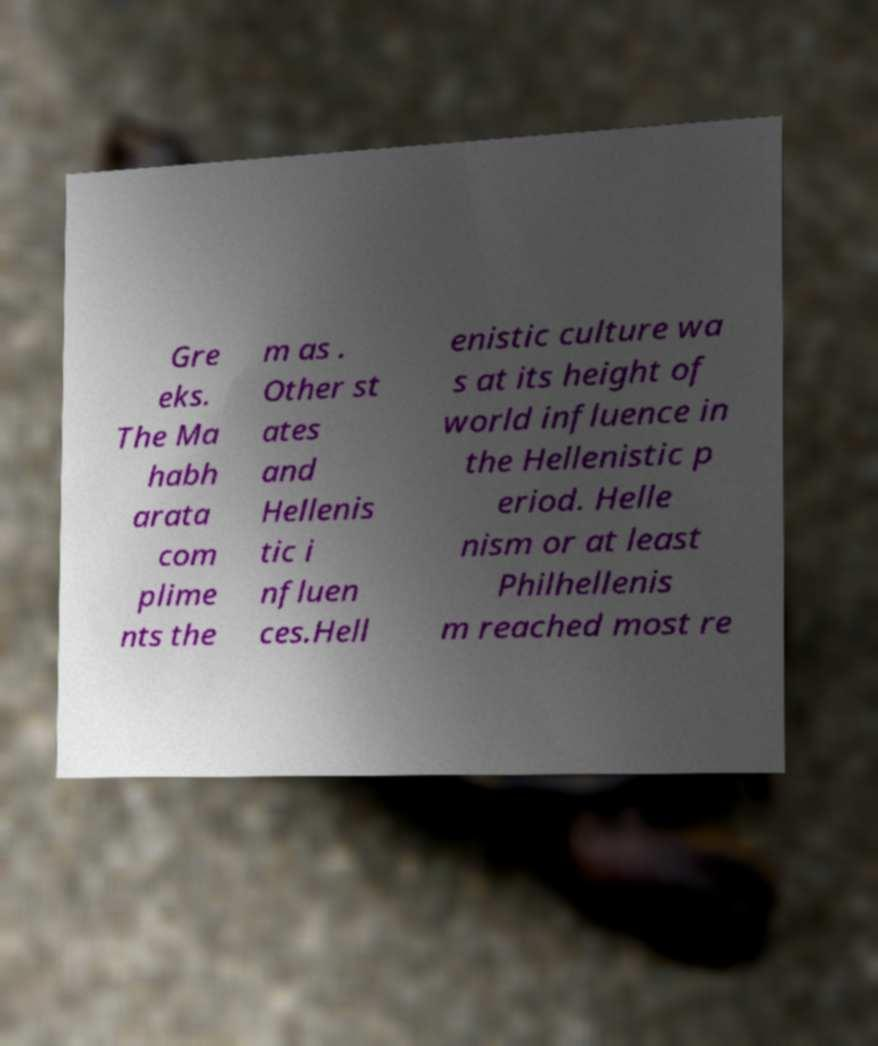Can you accurately transcribe the text from the provided image for me? Gre eks. The Ma habh arata com plime nts the m as . Other st ates and Hellenis tic i nfluen ces.Hell enistic culture wa s at its height of world influence in the Hellenistic p eriod. Helle nism or at least Philhellenis m reached most re 